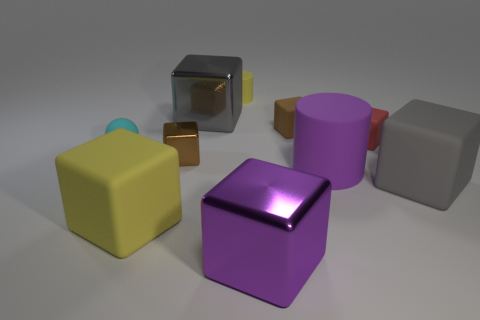There is a small brown object behind the cyan object; how many small spheres are right of it?
Your answer should be very brief. 0. What color is the metal block that is on the right side of the yellow object that is behind the cyan ball?
Your answer should be very brief. Purple. What is the block that is to the left of the small cylinder and behind the tiny brown metal cube made of?
Keep it short and to the point. Metal. There is a yellow object right of the large yellow matte thing; does it have the same shape as the cyan thing?
Offer a very short reply. No. What number of things are both on the left side of the gray matte object and to the right of the small brown matte object?
Offer a terse response. 2. There is a small object to the right of the small brown matte thing; what shape is it?
Provide a succinct answer. Cube. Is the shape of the red matte object the same as the brown object left of the tiny yellow thing?
Keep it short and to the point. Yes. Is there a big metallic object to the right of the big cube behind the brown block that is to the right of the tiny cylinder?
Your answer should be very brief. Yes. What size is the red matte object in front of the yellow matte cylinder?
Give a very brief answer. Small. What is the material of the brown object that is the same size as the brown rubber cube?
Offer a very short reply. Metal. 